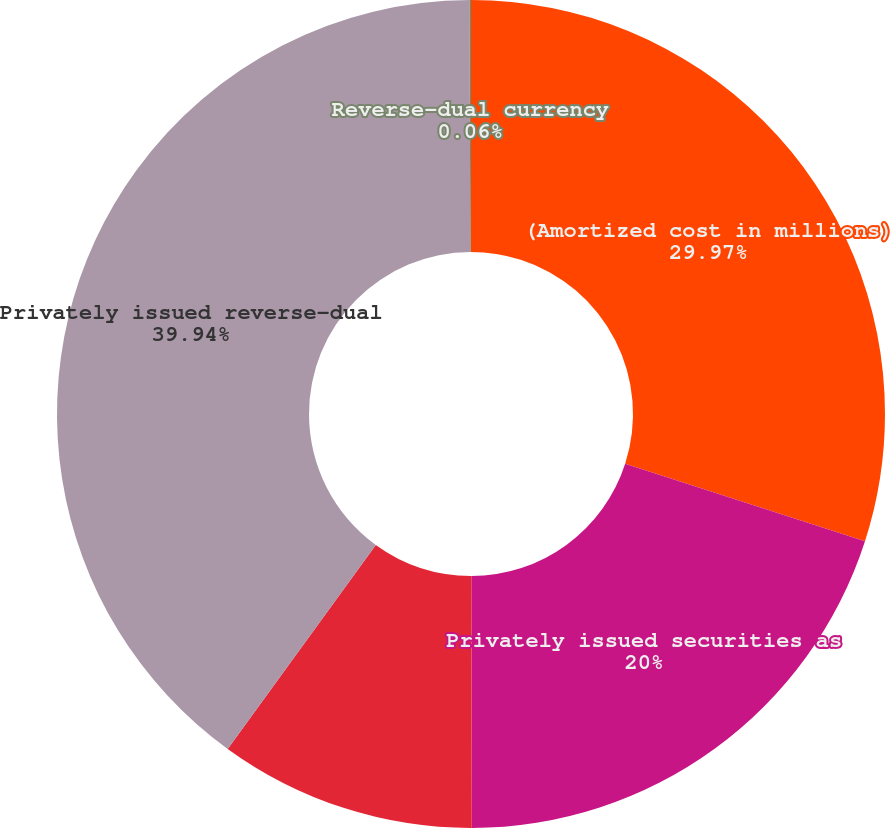<chart> <loc_0><loc_0><loc_500><loc_500><pie_chart><fcel>(Amortized cost in millions)<fcel>Privately issued securities as<fcel>Privately issued securities<fcel>Privately issued reverse-dual<fcel>Reverse-dual currency<nl><fcel>29.97%<fcel>20.0%<fcel>10.03%<fcel>39.94%<fcel>0.06%<nl></chart> 